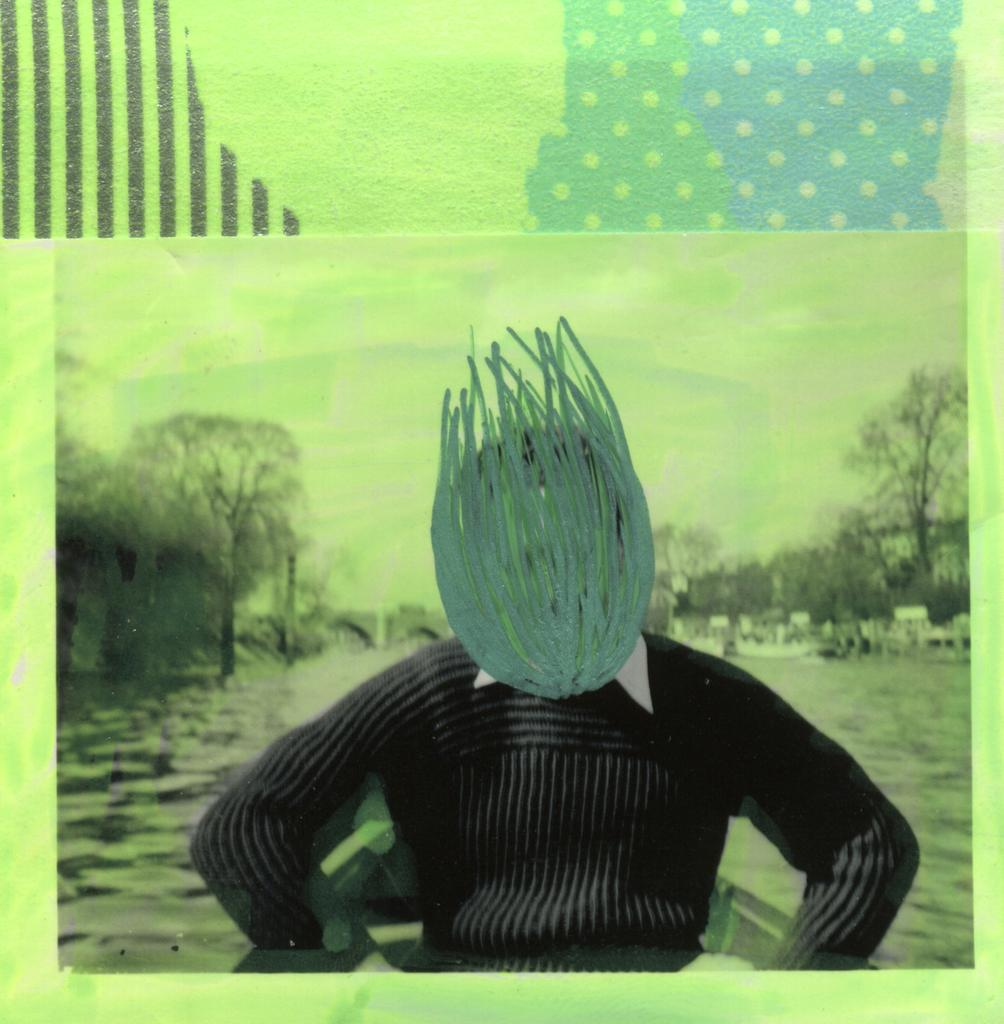What is the main subject of the photo in the image? The photo contains a man sitting on a boat. What can be seen in the background of the photo? There is water, trees, and the sky visible in the background of the photo. Where is the sack of flour stored in the image? There is no sack of flour present in the image. What type of paste is being used to create the drawing in the image? There is no drawing or paste present in the image. 